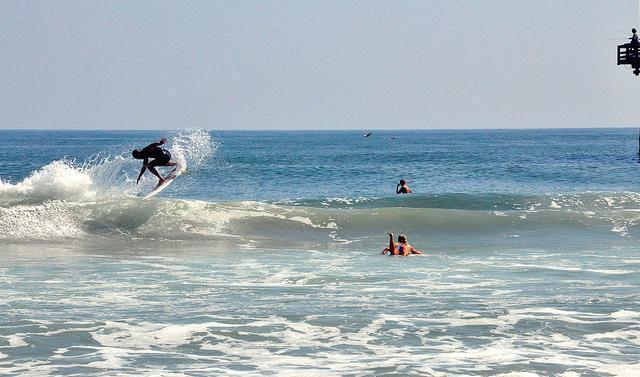How many people are in the water?
Give a very brief answer. 3. 